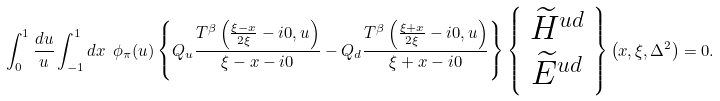Convert formula to latex. <formula><loc_0><loc_0><loc_500><loc_500>\int _ { 0 } ^ { 1 } \frac { d u } { u } \int _ { - 1 } ^ { 1 } d x \ \phi _ { \pi } ( u ) \left \{ Q _ { u } \frac { T ^ { \beta } \left ( \frac { \xi - x } { 2 \xi } - i 0 , u \right ) } { \xi - x - i 0 } - Q _ { d } \frac { T ^ { \beta } \left ( \frac { \xi + x } { 2 \xi } - i 0 , u \right ) } { \xi + x - i 0 } \right \} \left \{ \begin{array} { c } \widetilde { H } ^ { u d } \\ \widetilde { E } ^ { u d } \end{array} \right \} \left ( x , \xi , \Delta ^ { 2 } \right ) = 0 .</formula> 